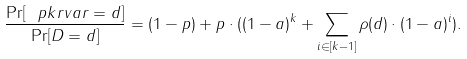<formula> <loc_0><loc_0><loc_500><loc_500>\frac { \Pr [ \ p k r v a r = d ] } { \Pr [ D = d ] } = ( 1 - p ) + p \cdot ( ( 1 - a ) ^ { k } + \sum _ { i \in [ k - 1 ] } \rho ( d ) \cdot ( 1 - a ) ^ { i } ) .</formula> 